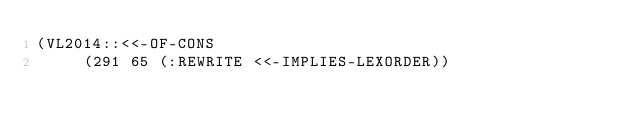<code> <loc_0><loc_0><loc_500><loc_500><_Lisp_>(VL2014::<<-OF-CONS
     (291 65 (:REWRITE <<-IMPLIES-LEXORDER))</code> 